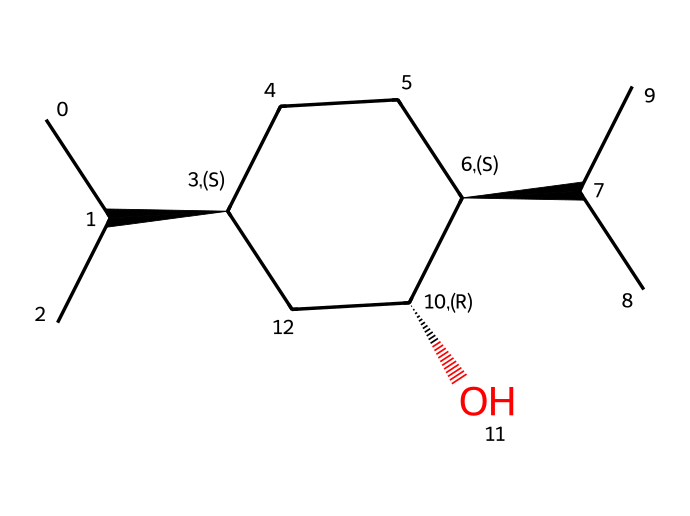What is the name of this chemical? The SMILES representation maps to the molecular structure of menthol, which is a common flavoring and fragrance compound known for its cooling sensation.
Answer: menthol How many carbon atoms are present? By analyzing the SMILES notation, there are 10 carbon atoms represented in the structure of menthol. Each 'C' in the SMILES corresponds to one carbon atom.
Answer: 10 What type of functional group is present? The structure contains a hydroxyl group (-OH), which is indicated by the presence of 'O' in the SMILES notation, making it an alcohol.
Answer: alcohol What is the stereochemistry of menthol? The notation includes '@', indicating the presence of chiral centers. In menthol, these chiral centers contribute to its specific three-dimensional shape, indicating that it has a specific stereochemistry.
Answer: chiral What effect does menthol have on skin when applied topically? Menthol acts as a cooling agent that provides relief from pain and has a soothing effect when applied to the skin, often used in muscle rubs for its analgesic properties.
Answer: cooling How many rings does the structure contain? Analyzing the structure reveals there are no cyclic structures or rings present in menthol's molecular composition; it is an acyclic compound.
Answer: 0 